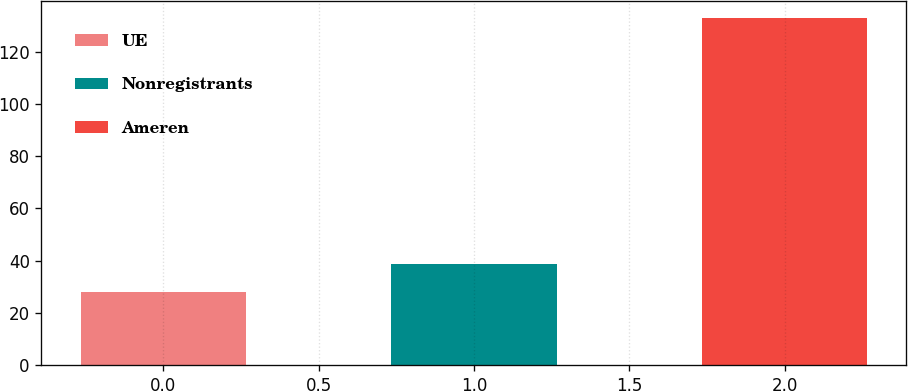Convert chart. <chart><loc_0><loc_0><loc_500><loc_500><bar_chart><fcel>UE<fcel>Nonregistrants<fcel>Ameren<nl><fcel>28<fcel>38.5<fcel>133<nl></chart> 